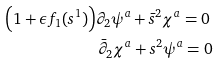Convert formula to latex. <formula><loc_0><loc_0><loc_500><loc_500>& \Big { ( } 1 + \epsilon f _ { 1 } ( s ^ { 1 } ) \Big { ) } \partial _ { 2 } \psi ^ { a } + \bar { s } ^ { 2 } \chi ^ { a } = 0 \\ & { \, } { \, } { \, } { \, } { \, } { \, } { \, } { \, } { \, } { \, } { \, } { \, } { \, } { \, } { \, } { \, } { \, } { \, } { \, } { \, } { \, } { \, } { \, } { \, } { \, } { \, } { \, } { \, } { \, } { \, } { \, } { \, } { \, } { \, } { \, } { \, } { \, } { \, } { \, } { \, } { \, } { \, } \bar { \partial } _ { 2 } \chi ^ { a } + s ^ { 2 } \psi ^ { a } = 0</formula> 